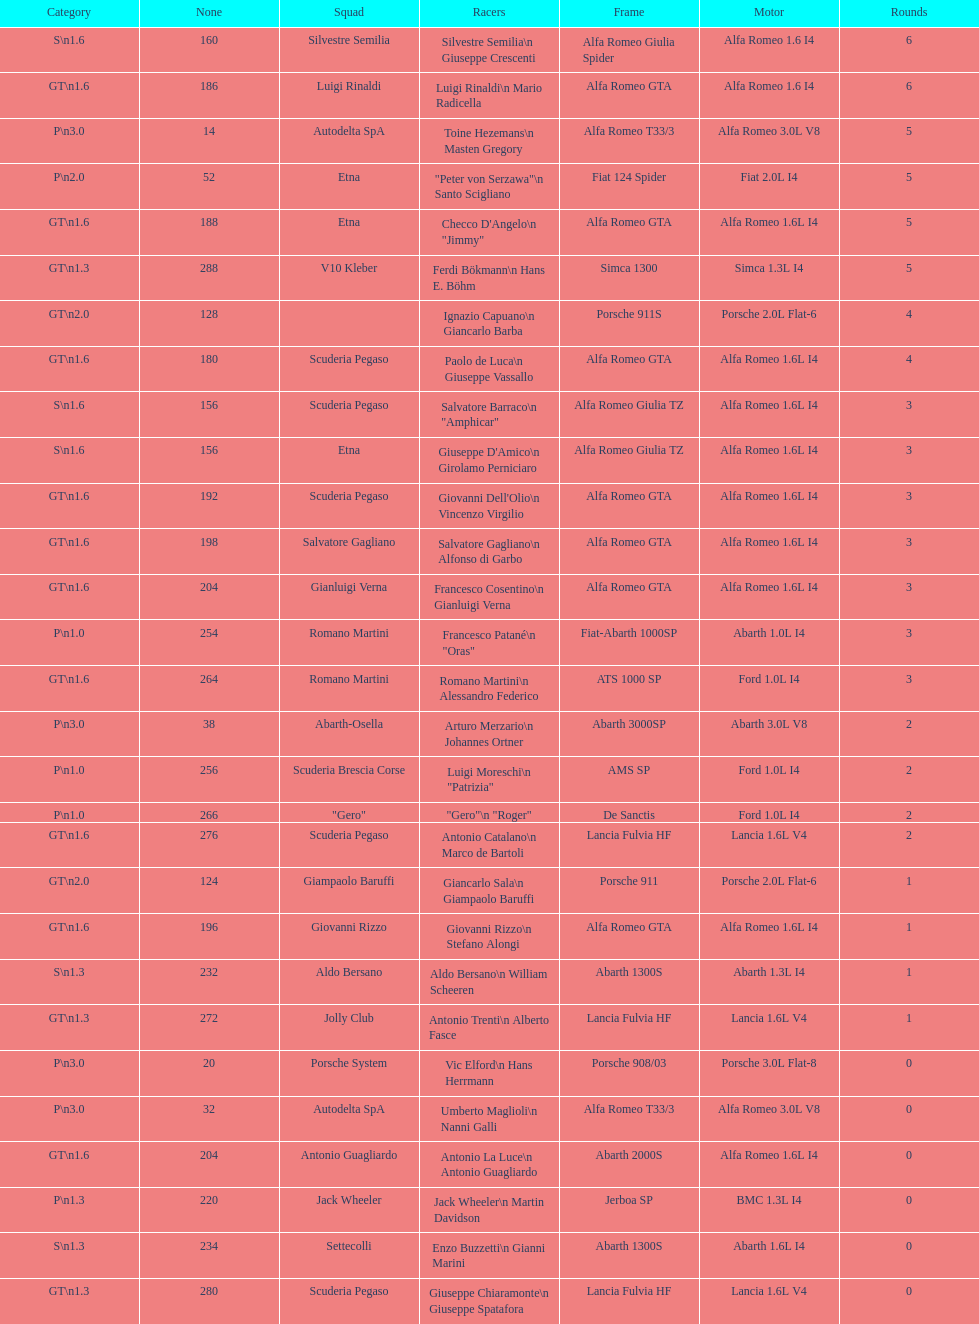6? GT 1.6. 